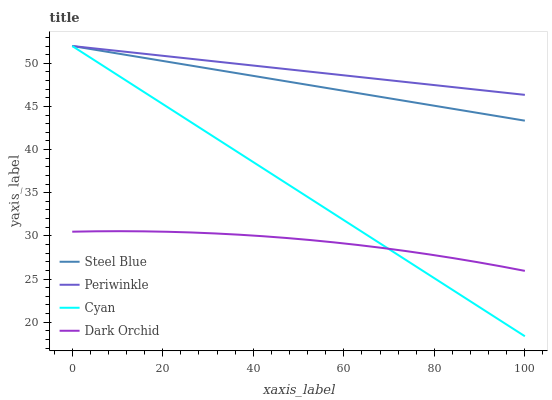Does Dark Orchid have the minimum area under the curve?
Answer yes or no. Yes. Does Periwinkle have the maximum area under the curve?
Answer yes or no. Yes. Does Steel Blue have the minimum area under the curve?
Answer yes or no. No. Does Steel Blue have the maximum area under the curve?
Answer yes or no. No. Is Periwinkle the smoothest?
Answer yes or no. Yes. Is Dark Orchid the roughest?
Answer yes or no. Yes. Is Steel Blue the smoothest?
Answer yes or no. No. Is Steel Blue the roughest?
Answer yes or no. No. Does Cyan have the lowest value?
Answer yes or no. Yes. Does Steel Blue have the lowest value?
Answer yes or no. No. Does Steel Blue have the highest value?
Answer yes or no. Yes. Does Dark Orchid have the highest value?
Answer yes or no. No. Is Dark Orchid less than Periwinkle?
Answer yes or no. Yes. Is Periwinkle greater than Dark Orchid?
Answer yes or no. Yes. Does Periwinkle intersect Cyan?
Answer yes or no. Yes. Is Periwinkle less than Cyan?
Answer yes or no. No. Is Periwinkle greater than Cyan?
Answer yes or no. No. Does Dark Orchid intersect Periwinkle?
Answer yes or no. No. 